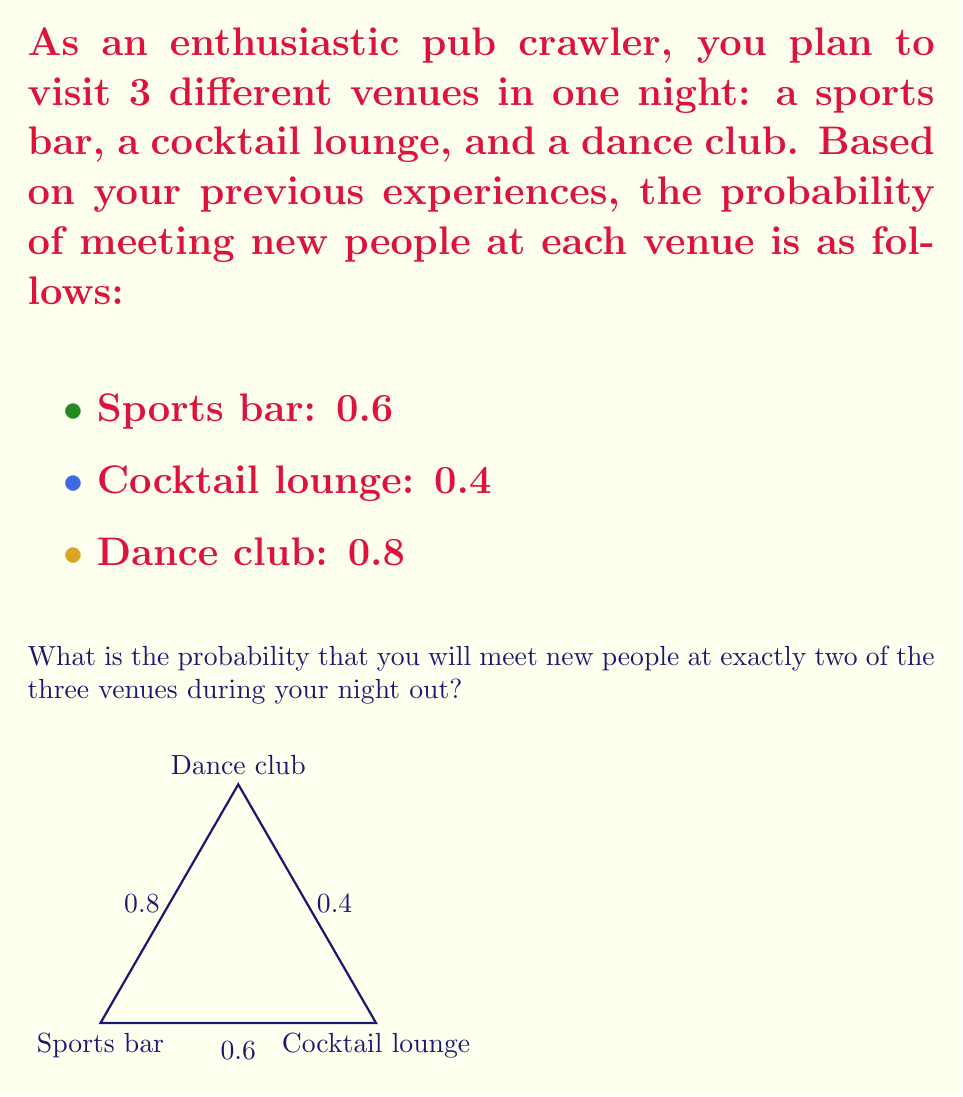Show me your answer to this math problem. Let's approach this step-by-step using the concept of probability:

1) First, we need to calculate the probability of meeting new people (success) and not meeting new people (failure) at each venue:

   Sports bar: P(success) = 0.6, P(failure) = 1 - 0.6 = 0.4
   Cocktail lounge: P(success) = 0.4, P(failure) = 1 - 0.4 = 0.6
   Dance club: P(success) = 0.8, P(failure) = 1 - 0.8 = 0.2

2) To meet new people at exactly two venues, we have three possible scenarios:
   a) Success at sports bar and cocktail lounge, failure at dance club
   b) Success at sports bar and dance club, failure at cocktail lounge
   c) Success at cocktail lounge and dance club, failure at sports bar

3) Let's calculate the probability of each scenario:

   a) $P(a) = 0.6 \times 0.4 \times 0.2 = 0.048$
   b) $P(b) = 0.6 \times 0.6 \times 0.8 = 0.288$
   c) $P(c) = 0.4 \times 0.6 \times 0.8 = 0.192$

4) The total probability is the sum of these individual probabilities:

   $P(\text{exactly two successes}) = P(a) + P(b) + P(c)$
   $= 0.048 + 0.288 + 0.192$
   $= 0.528$

Therefore, the probability of meeting new people at exactly two of the three venues is 0.528 or 52.8%.
Answer: 0.528 